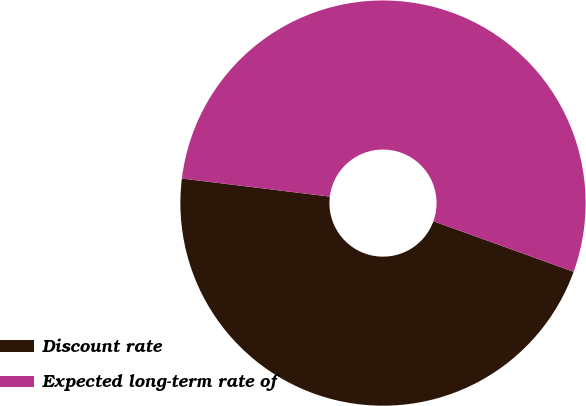<chart> <loc_0><loc_0><loc_500><loc_500><pie_chart><fcel>Discount rate<fcel>Expected long-term rate of<nl><fcel>46.43%<fcel>53.57%<nl></chart> 